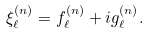Convert formula to latex. <formula><loc_0><loc_0><loc_500><loc_500>\xi _ { \ell } ^ { ( n ) } = f _ { \ell } ^ { ( n ) } + i g _ { \ell } ^ { ( n ) } .</formula> 